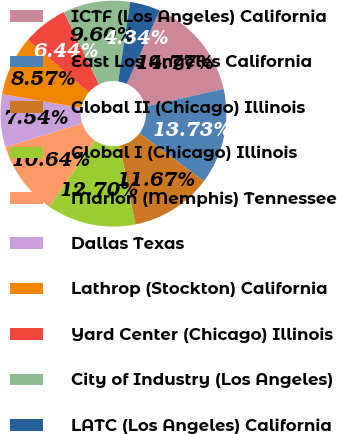Convert chart. <chart><loc_0><loc_0><loc_500><loc_500><pie_chart><fcel>ICTF (Los Angeles) California<fcel>East Los Angeles California<fcel>Global II (Chicago) Illinois<fcel>Global I (Chicago) Illinois<fcel>Marion (Memphis) Tennessee<fcel>Dallas Texas<fcel>Lathrop (Stockton) California<fcel>Yard Center (Chicago) Illinois<fcel>City of Industry (Los Angeles)<fcel>LATC (Los Angeles) California<nl><fcel>14.77%<fcel>13.73%<fcel>11.67%<fcel>12.7%<fcel>10.64%<fcel>7.54%<fcel>8.57%<fcel>6.44%<fcel>9.6%<fcel>4.34%<nl></chart> 